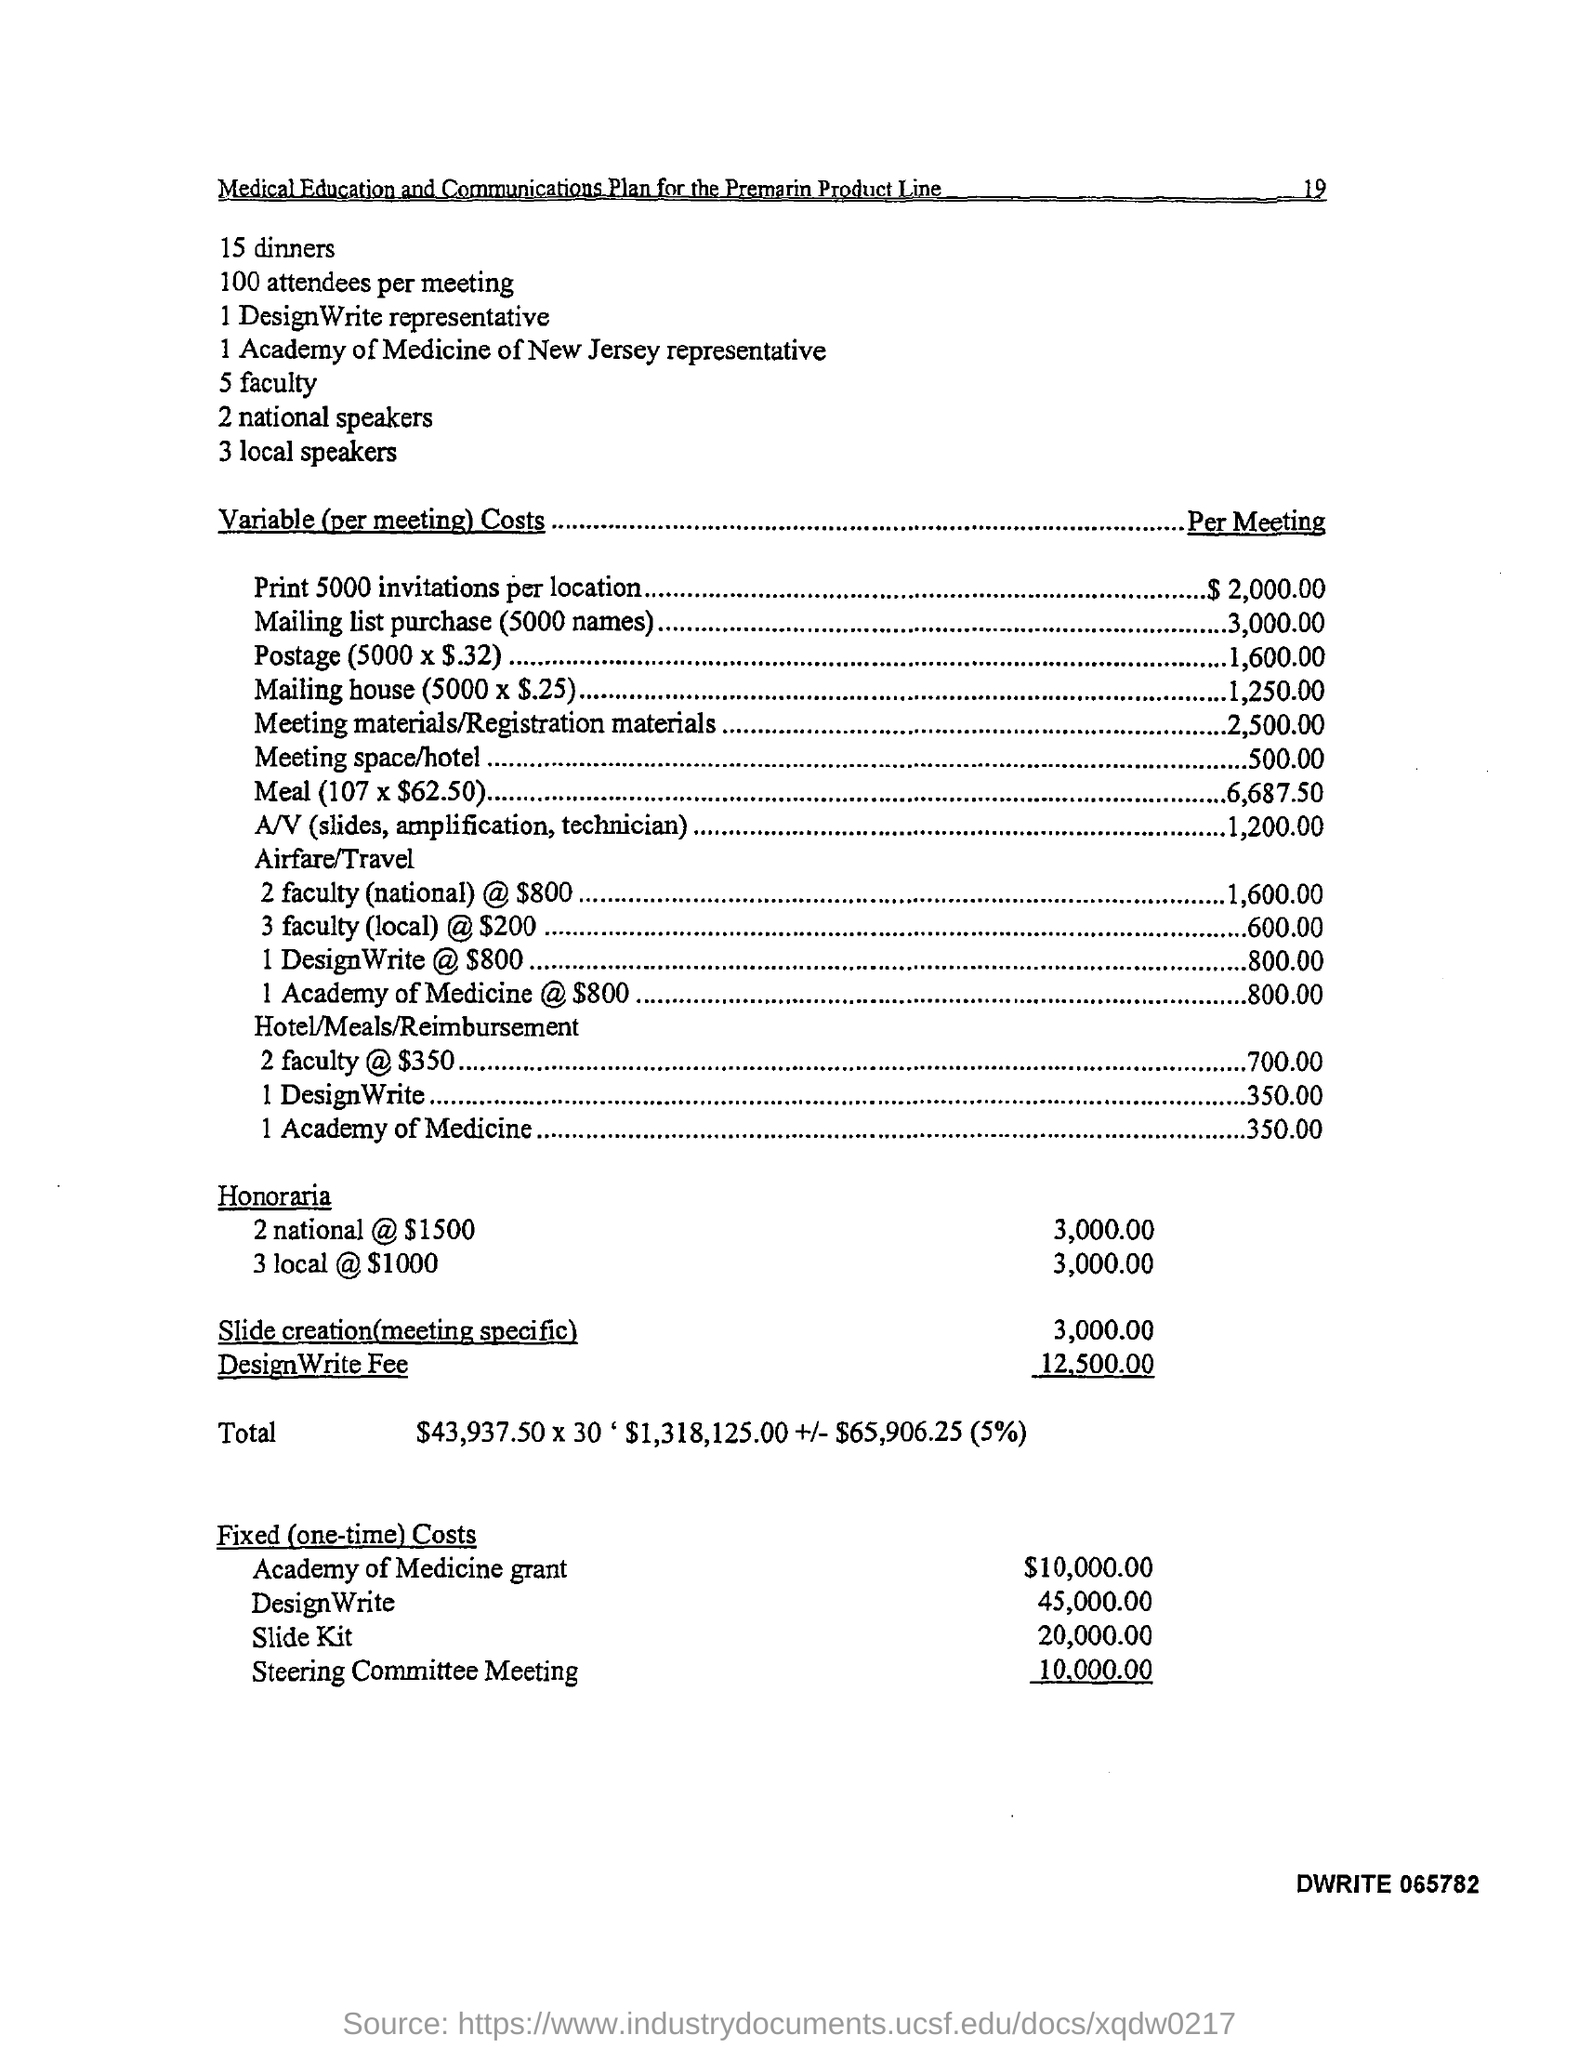Draw attention to some important aspects in this diagram. There were 100 attendees per meeting. There are five faculties in total. There are 15 dinners. 